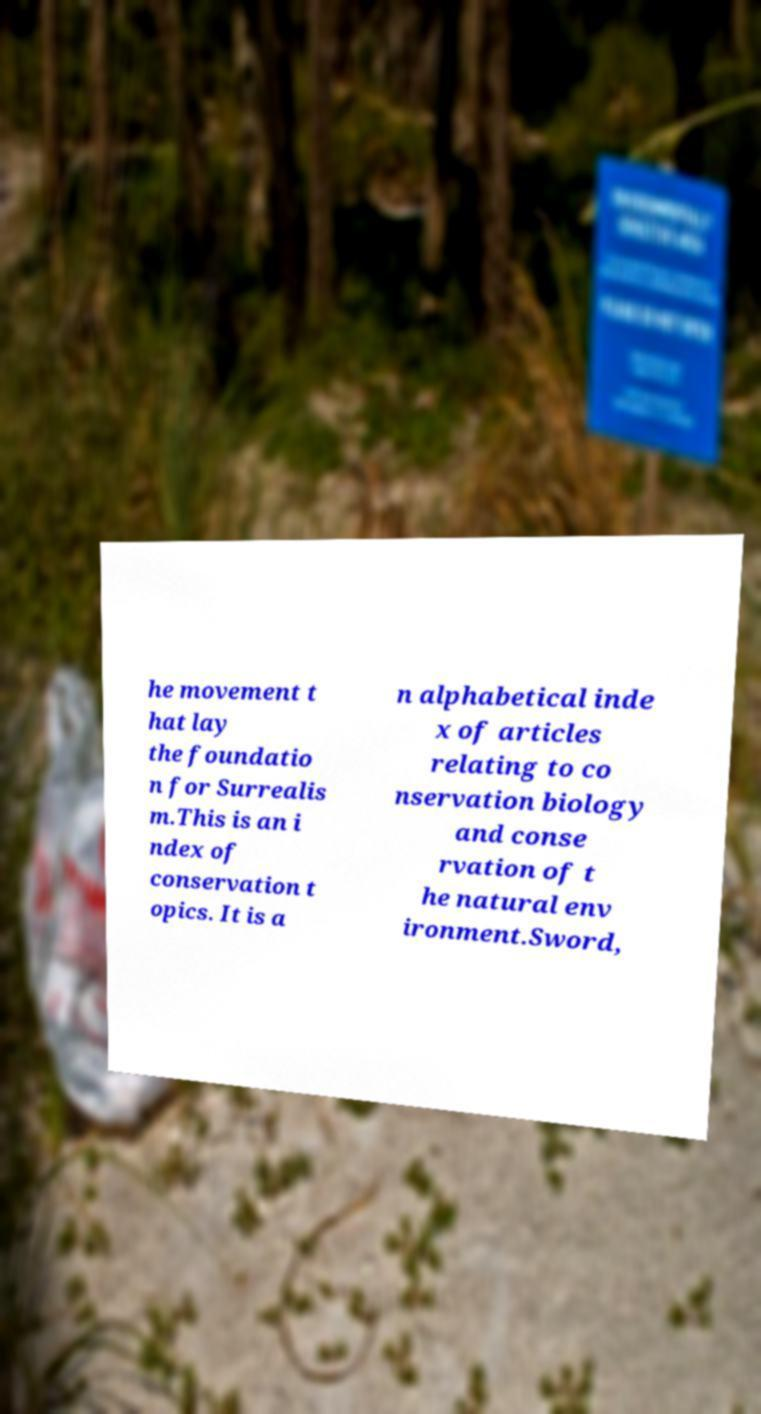Can you accurately transcribe the text from the provided image for me? he movement t hat lay the foundatio n for Surrealis m.This is an i ndex of conservation t opics. It is a n alphabetical inde x of articles relating to co nservation biology and conse rvation of t he natural env ironment.Sword, 